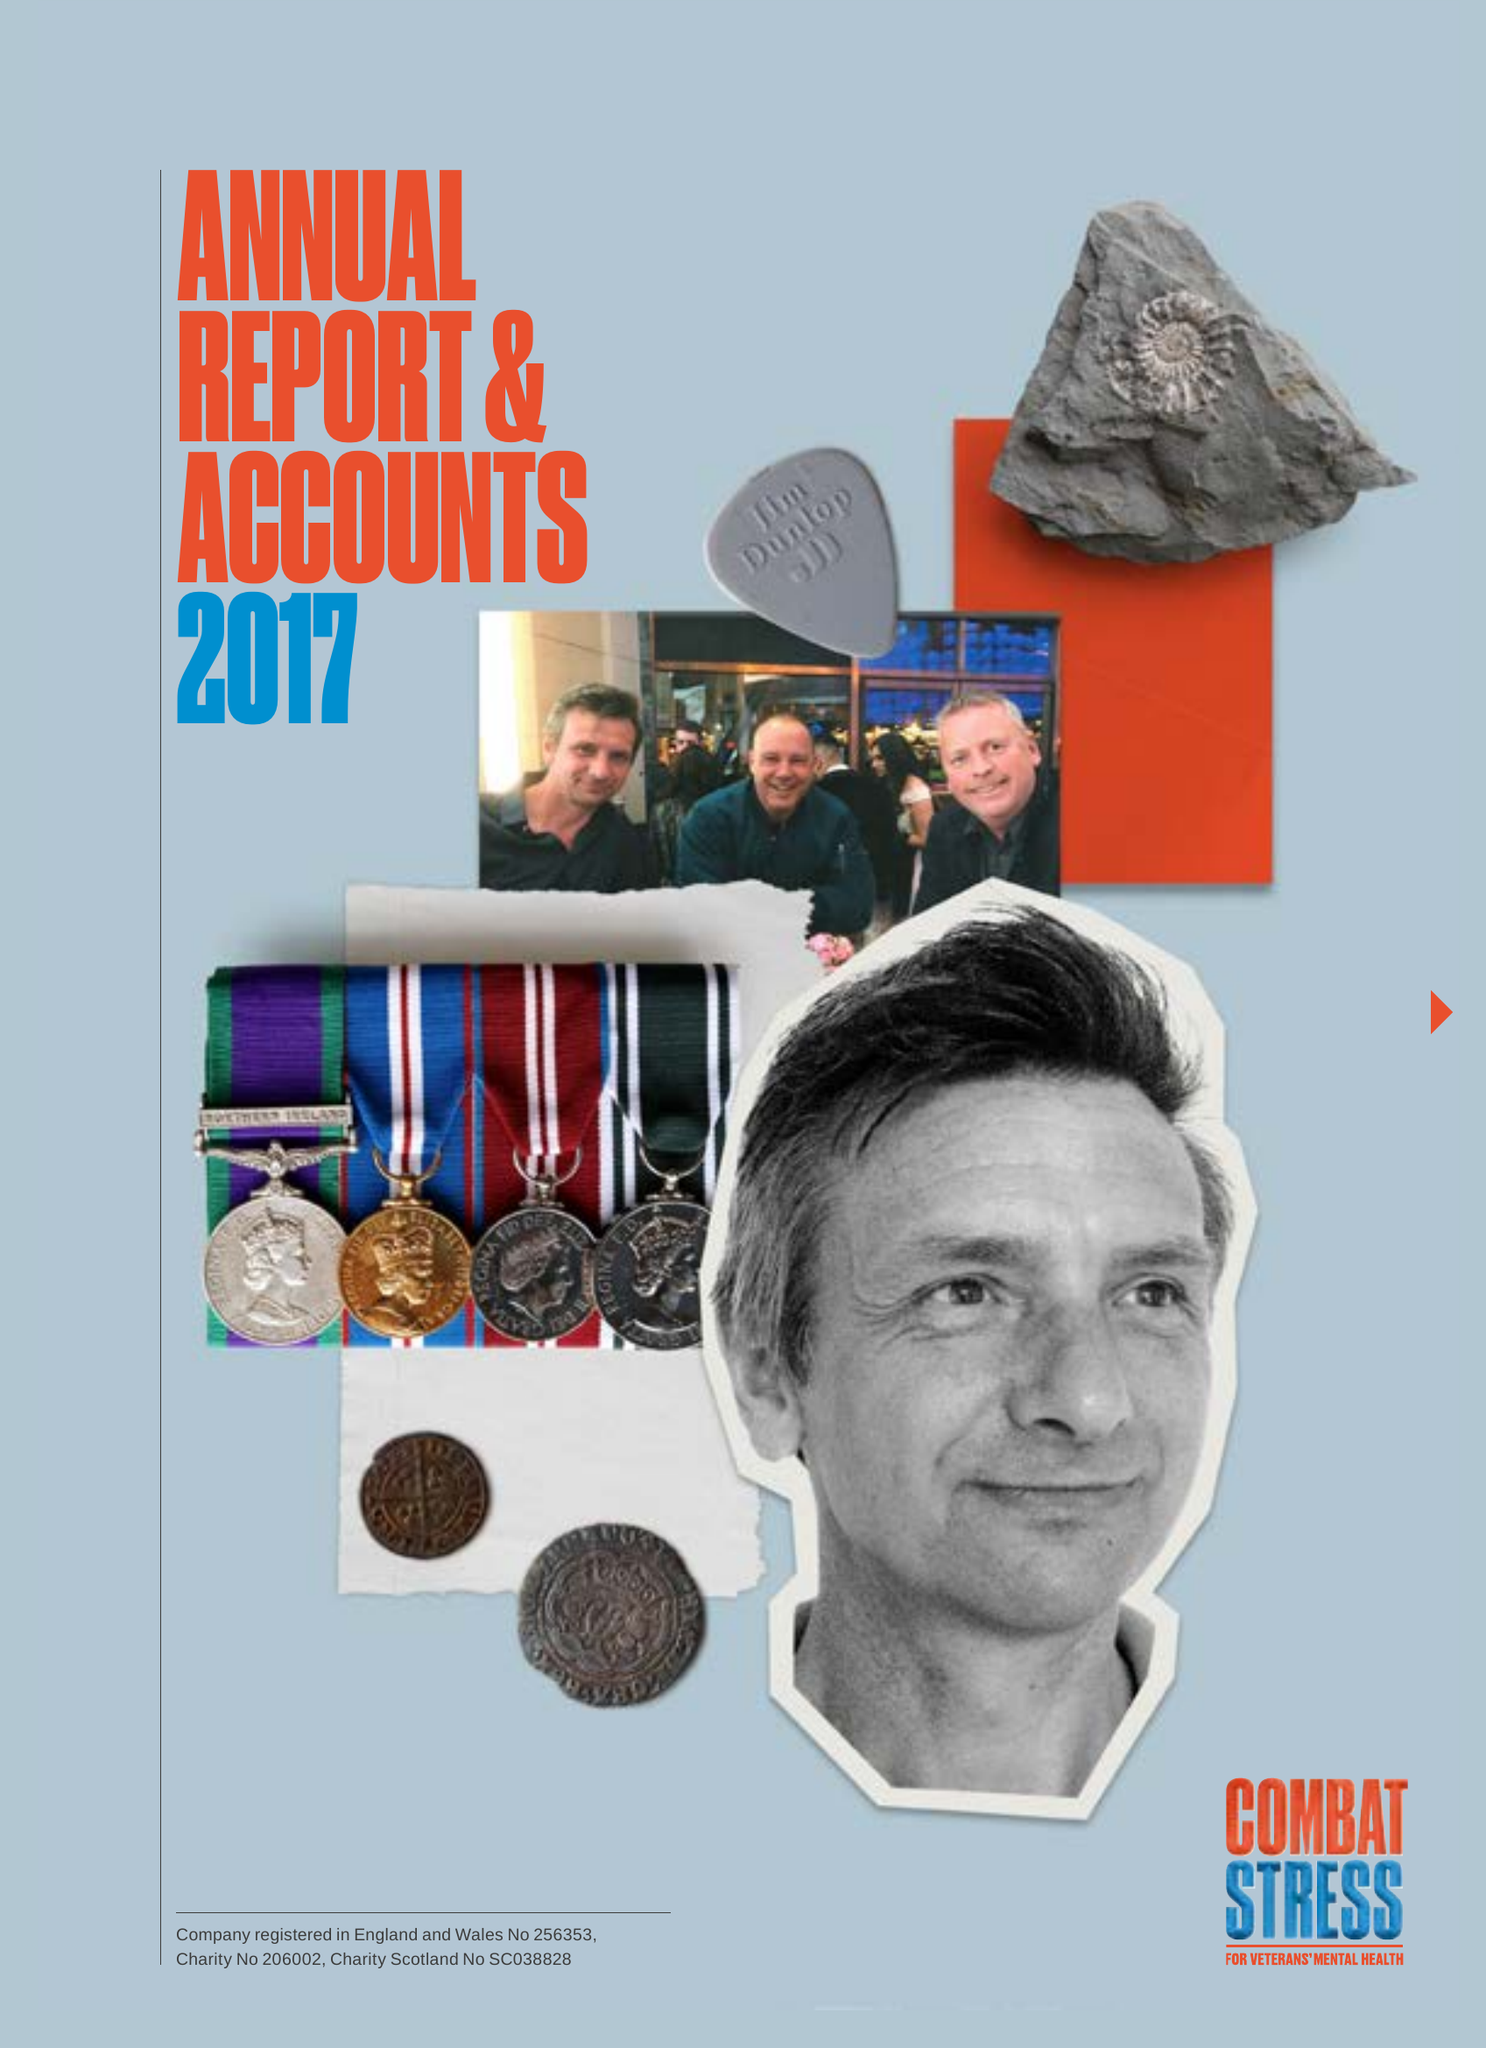What is the value for the address__post_town?
Answer the question using a single word or phrase. LEATHERHEAD 